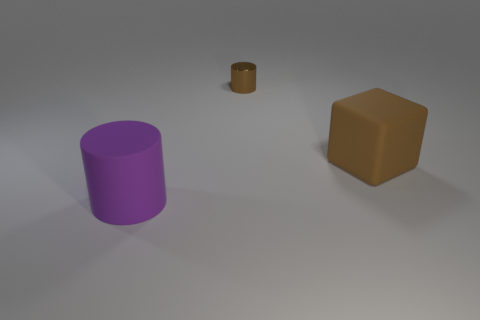Add 3 brown matte things. How many objects exist? 6 Subtract all cubes. How many objects are left? 2 Subtract all big rubber blocks. Subtract all purple things. How many objects are left? 1 Add 1 big brown rubber blocks. How many big brown rubber blocks are left? 2 Add 3 small objects. How many small objects exist? 4 Subtract 1 brown cylinders. How many objects are left? 2 